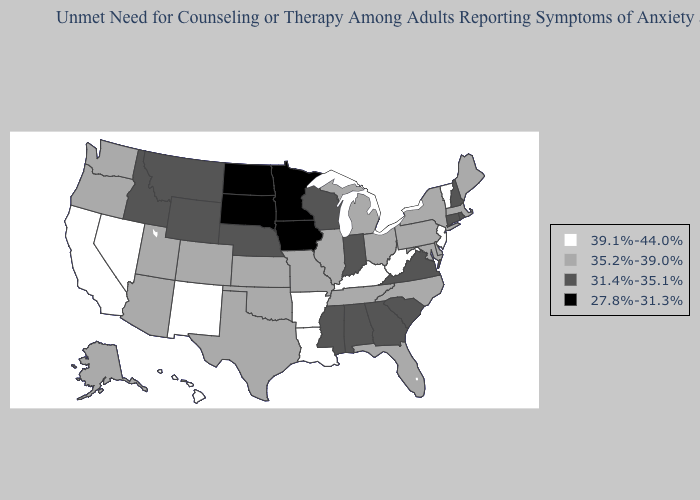Name the states that have a value in the range 35.2%-39.0%?
Keep it brief. Alaska, Arizona, Colorado, Delaware, Florida, Illinois, Kansas, Maine, Maryland, Massachusetts, Michigan, Missouri, New York, North Carolina, Ohio, Oklahoma, Oregon, Pennsylvania, Tennessee, Texas, Utah, Washington. Does Michigan have the highest value in the MidWest?
Quick response, please. Yes. Does Indiana have the same value as Louisiana?
Give a very brief answer. No. What is the value of Rhode Island?
Give a very brief answer. 31.4%-35.1%. Name the states that have a value in the range 27.8%-31.3%?
Quick response, please. Iowa, Minnesota, North Dakota, South Dakota. What is the value of Virginia?
Answer briefly. 31.4%-35.1%. Among the states that border Arkansas , which have the highest value?
Be succinct. Louisiana. What is the highest value in the USA?
Answer briefly. 39.1%-44.0%. Which states have the lowest value in the USA?
Keep it brief. Iowa, Minnesota, North Dakota, South Dakota. Name the states that have a value in the range 39.1%-44.0%?
Keep it brief. Arkansas, California, Hawaii, Kentucky, Louisiana, Nevada, New Jersey, New Mexico, Vermont, West Virginia. What is the value of North Dakota?
Short answer required. 27.8%-31.3%. Name the states that have a value in the range 39.1%-44.0%?
Answer briefly. Arkansas, California, Hawaii, Kentucky, Louisiana, Nevada, New Jersey, New Mexico, Vermont, West Virginia. Does Rhode Island have the lowest value in the USA?
Short answer required. No. What is the lowest value in states that border Mississippi?
Concise answer only. 31.4%-35.1%. Name the states that have a value in the range 39.1%-44.0%?
Concise answer only. Arkansas, California, Hawaii, Kentucky, Louisiana, Nevada, New Jersey, New Mexico, Vermont, West Virginia. 